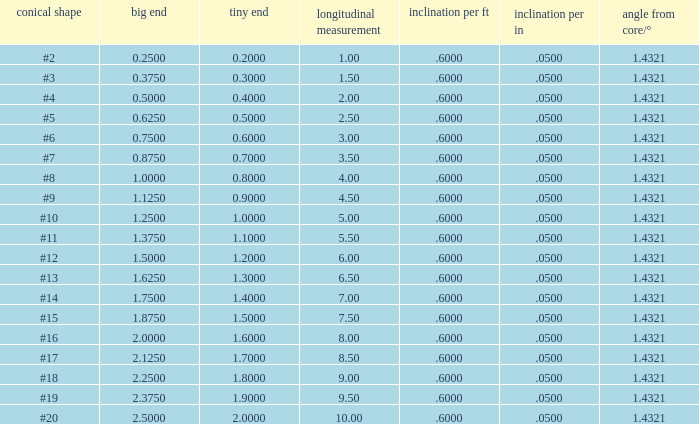Which Taper/in that has a Small end larger than 0.7000000000000001, and a Taper of #19, and a Large end larger than 2.375? None. 